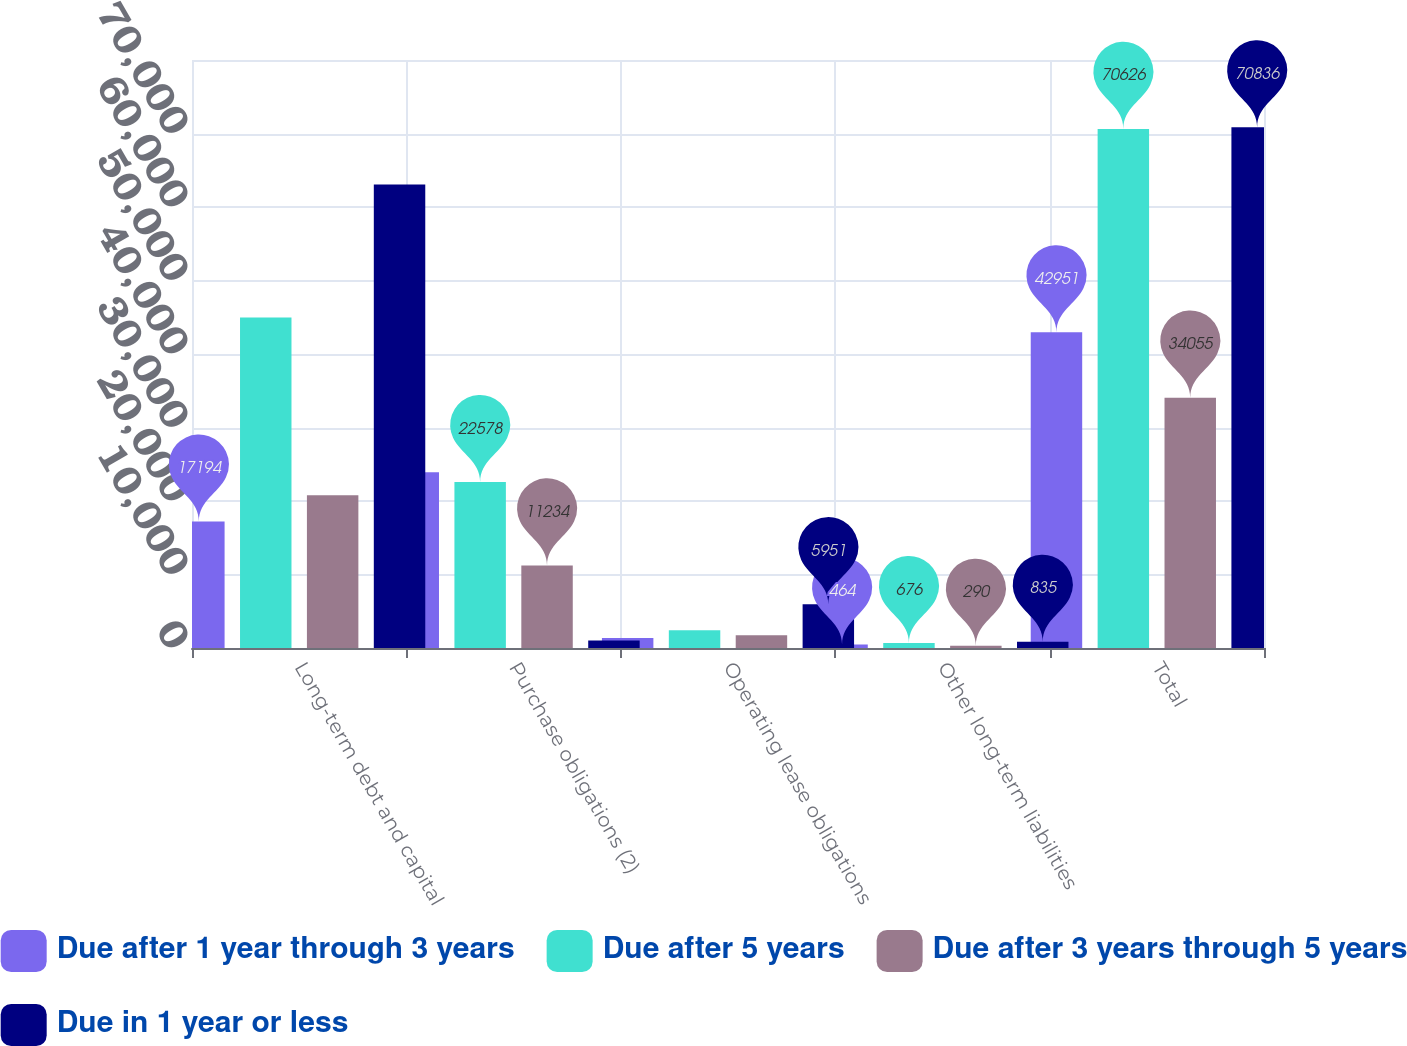Convert chart to OTSL. <chart><loc_0><loc_0><loc_500><loc_500><stacked_bar_chart><ecel><fcel>Long-term debt and capital<fcel>Purchase obligations (2)<fcel>Operating lease obligations<fcel>Other long-term liabilities<fcel>Total<nl><fcel>Due after 1 year through 3 years<fcel>17194<fcel>23918<fcel>1375<fcel>464<fcel>42951<nl><fcel>Due after 5 years<fcel>44962<fcel>22578<fcel>2410<fcel>676<fcel>70626<nl><fcel>Due after 3 years through 5 years<fcel>20799<fcel>11234<fcel>1732<fcel>290<fcel>34055<nl><fcel>Due in 1 year or less<fcel>63045<fcel>1005<fcel>5951<fcel>835<fcel>70836<nl></chart> 